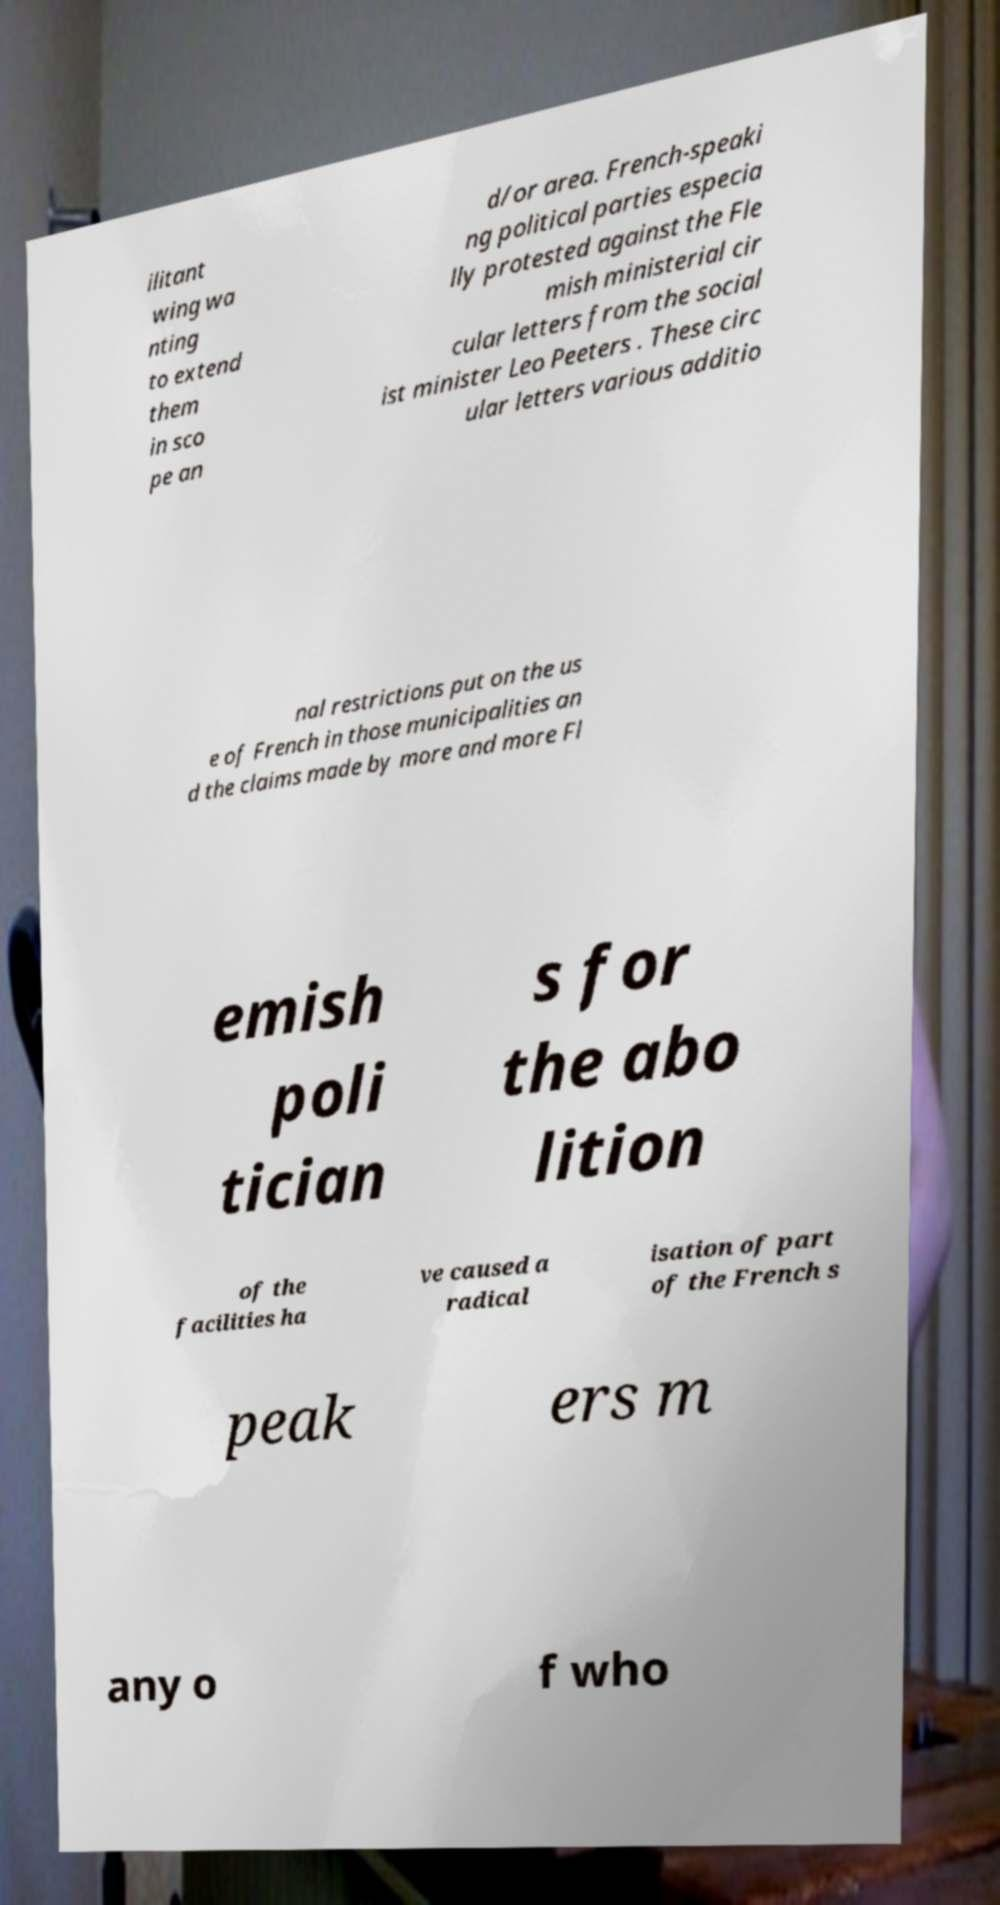For documentation purposes, I need the text within this image transcribed. Could you provide that? ilitant wing wa nting to extend them in sco pe an d/or area. French-speaki ng political parties especia lly protested against the Fle mish ministerial cir cular letters from the social ist minister Leo Peeters . These circ ular letters various additio nal restrictions put on the us e of French in those municipalities an d the claims made by more and more Fl emish poli tician s for the abo lition of the facilities ha ve caused a radical isation of part of the French s peak ers m any o f who 